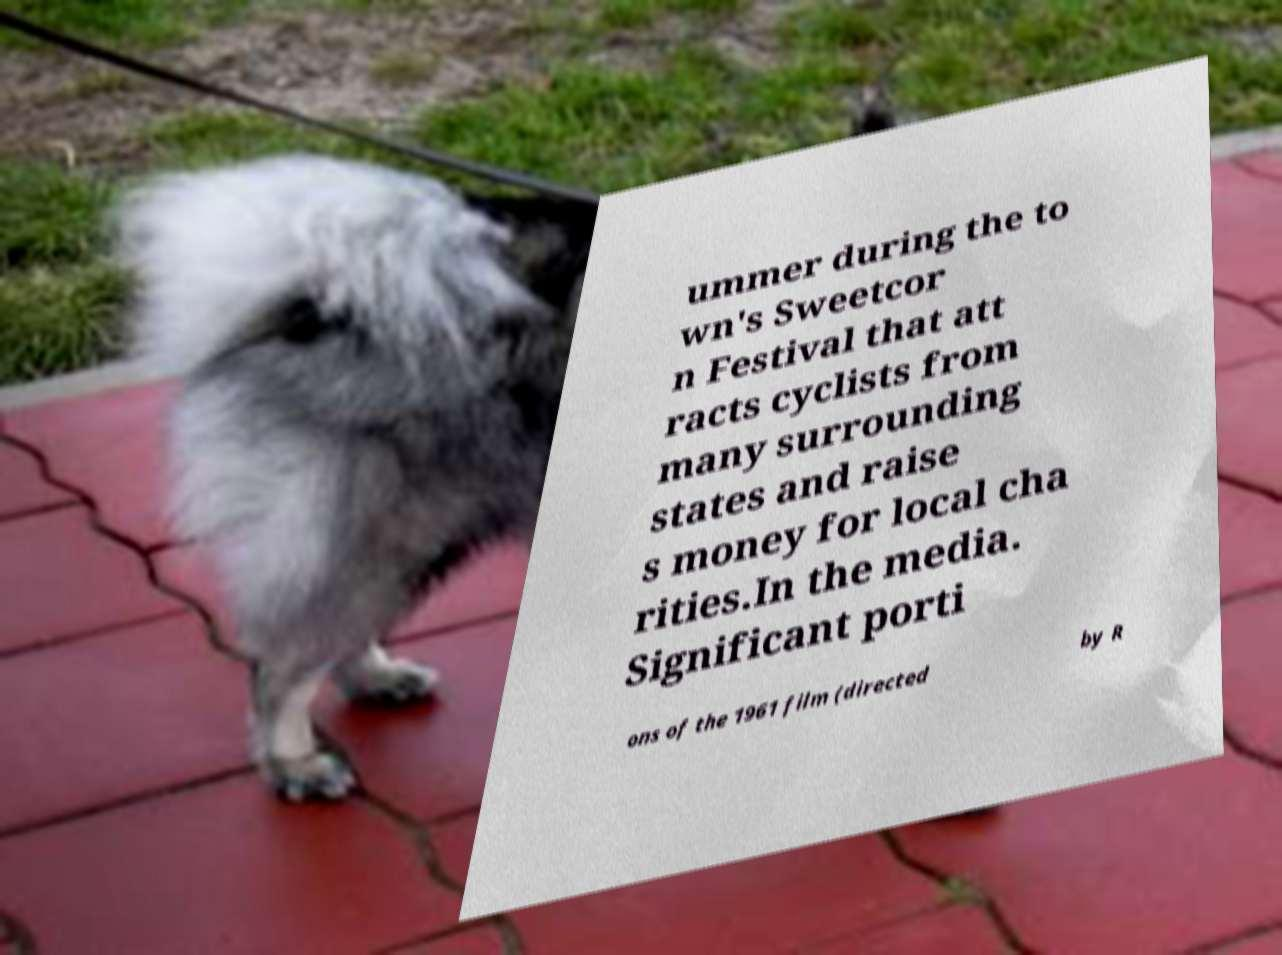Can you read and provide the text displayed in the image?This photo seems to have some interesting text. Can you extract and type it out for me? ummer during the to wn's Sweetcor n Festival that att racts cyclists from many surrounding states and raise s money for local cha rities.In the media. Significant porti ons of the 1961 film (directed by R 